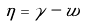Convert formula to latex. <formula><loc_0><loc_0><loc_500><loc_500>\eta = \gamma - w</formula> 